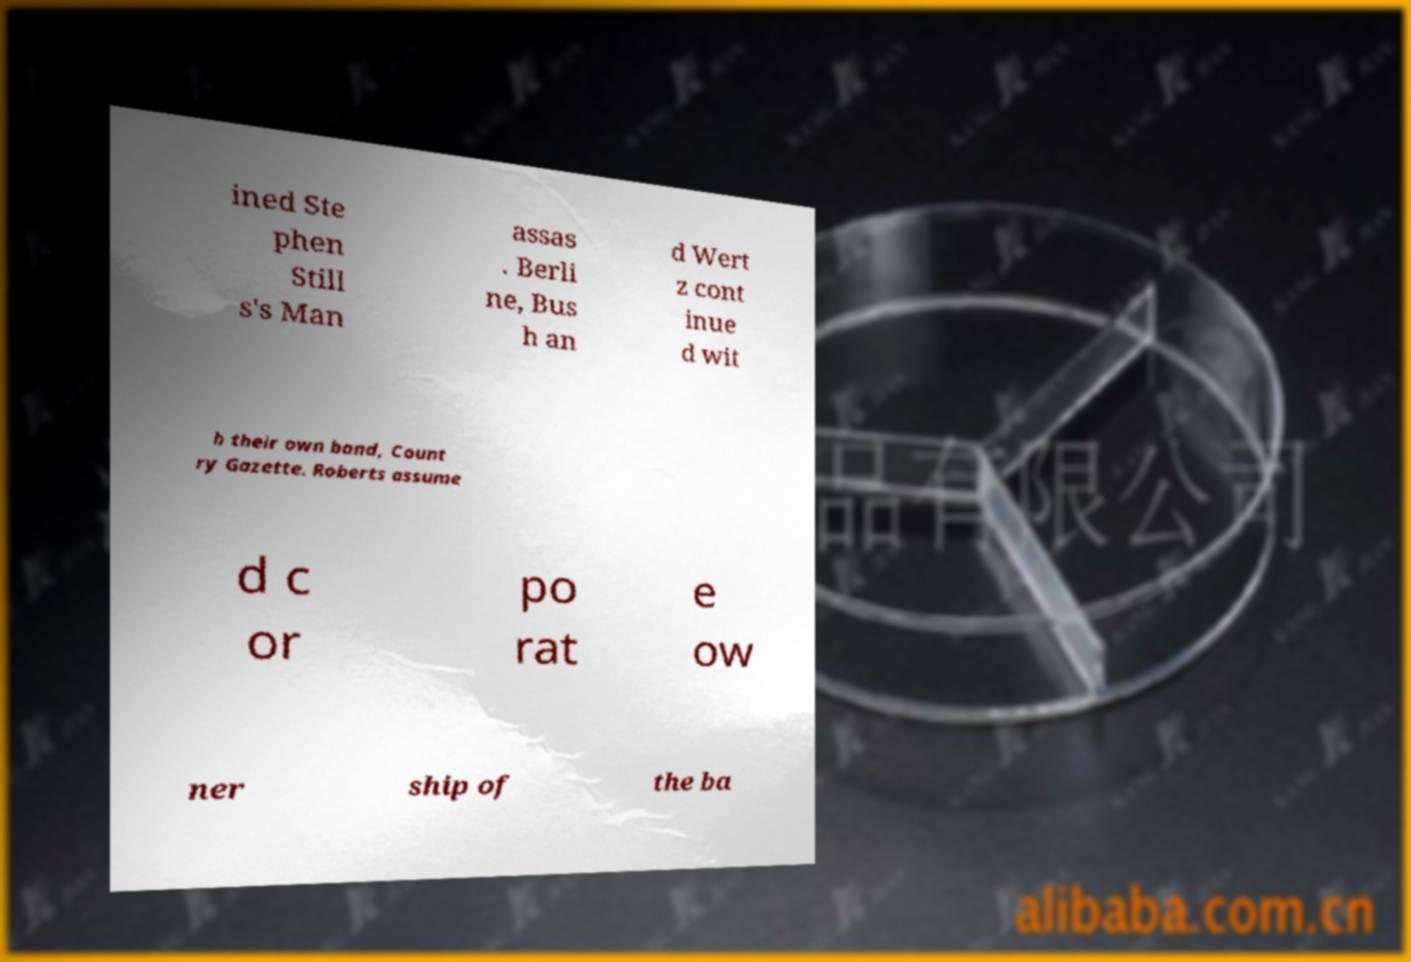Could you assist in decoding the text presented in this image and type it out clearly? ined Ste phen Still s's Man assas . Berli ne, Bus h an d Wert z cont inue d wit h their own band, Count ry Gazette. Roberts assume d c or po rat e ow ner ship of the ba 